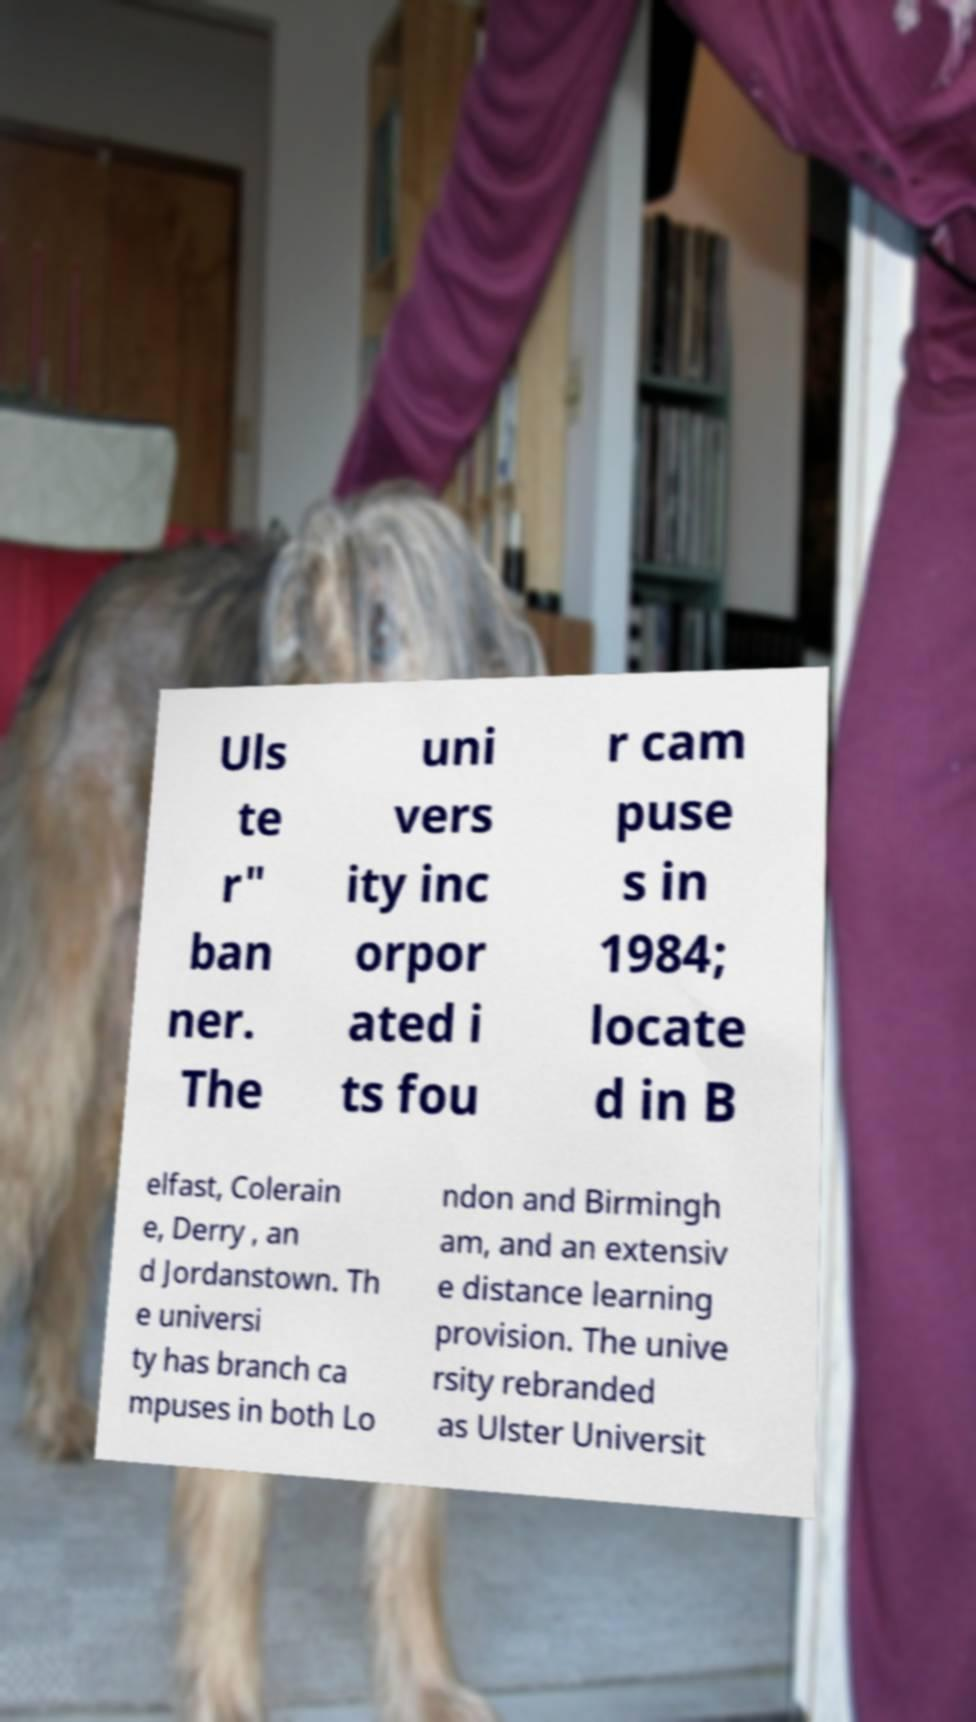Could you extract and type out the text from this image? Uls te r" ban ner. The uni vers ity inc orpor ated i ts fou r cam puse s in 1984; locate d in B elfast, Colerain e, Derry , an d Jordanstown. Th e universi ty has branch ca mpuses in both Lo ndon and Birmingh am, and an extensiv e distance learning provision. The unive rsity rebranded as Ulster Universit 